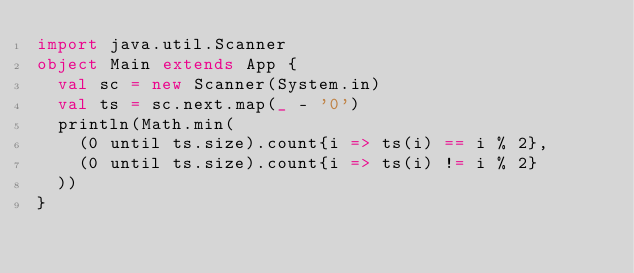<code> <loc_0><loc_0><loc_500><loc_500><_Scala_>import java.util.Scanner
object Main extends App {
  val sc = new Scanner(System.in)
  val ts = sc.next.map(_ - '0')
  println(Math.min(
    (0 until ts.size).count{i => ts(i) == i % 2},
    (0 until ts.size).count{i => ts(i) != i % 2}
  ))
}
</code> 